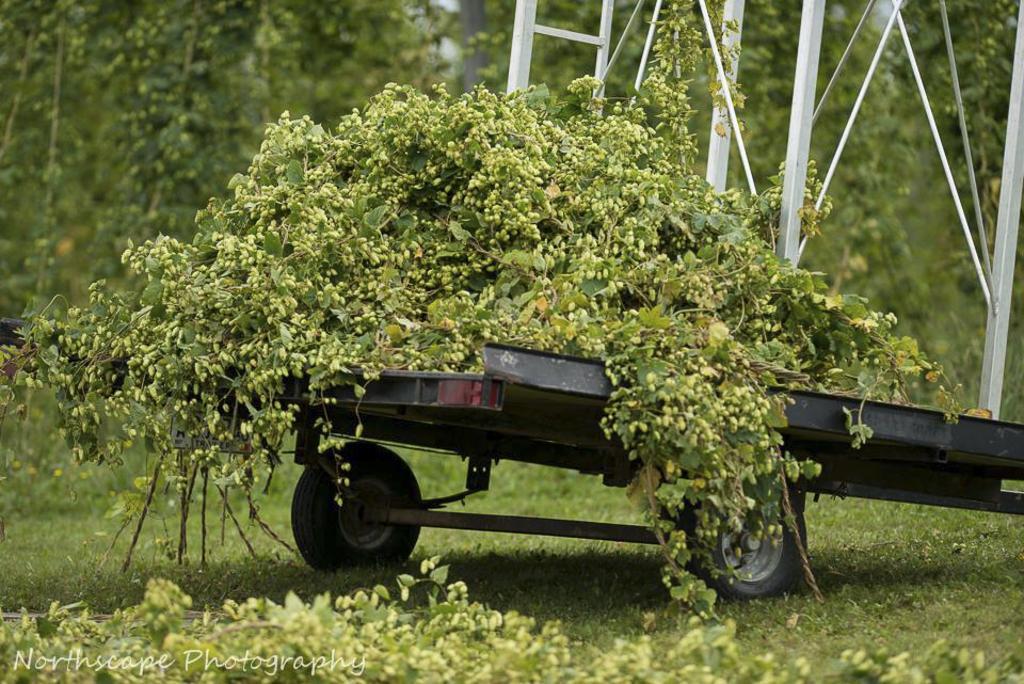Could you give a brief overview of what you see in this image? In this picture I can observe plants in the middle of the picture. On the bottom left side I can observe a watermark. In the background there are trees. 